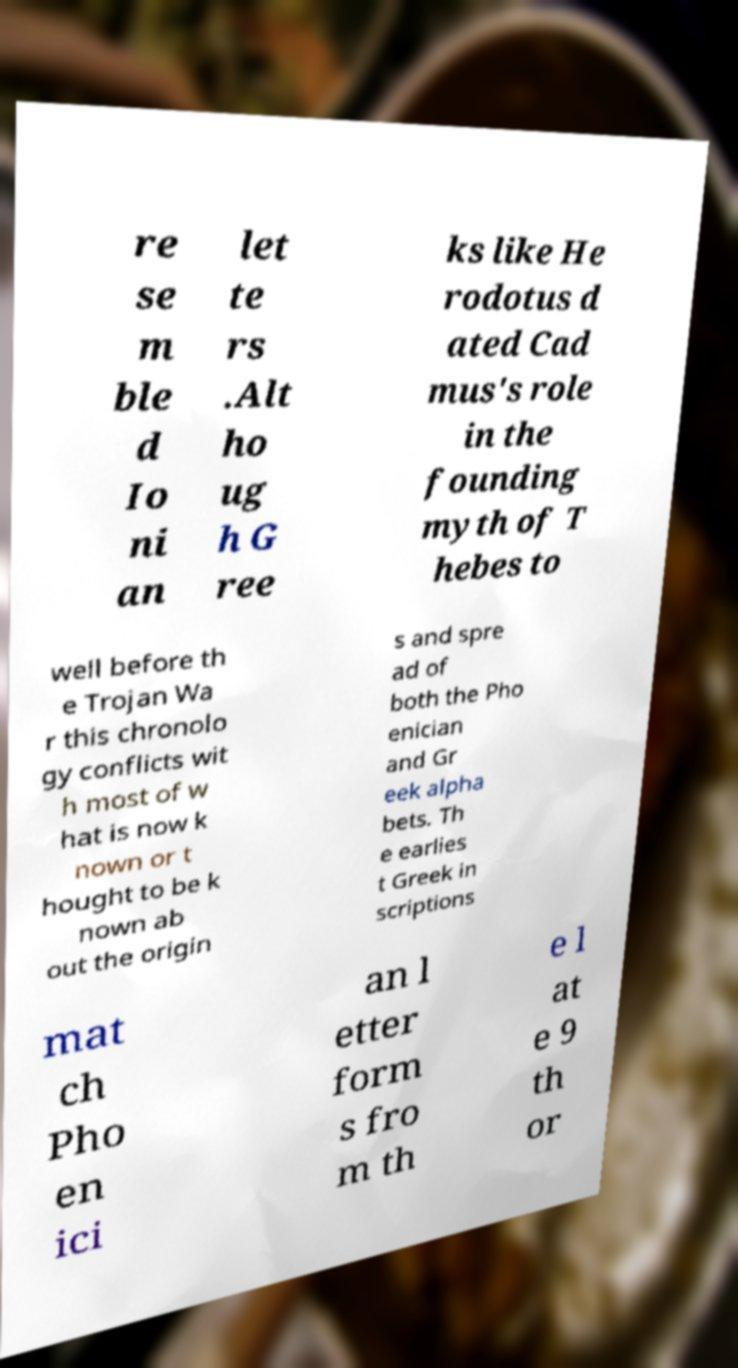Please identify and transcribe the text found in this image. re se m ble d Io ni an let te rs .Alt ho ug h G ree ks like He rodotus d ated Cad mus's role in the founding myth of T hebes to well before th e Trojan Wa r this chronolo gy conflicts wit h most of w hat is now k nown or t hought to be k nown ab out the origin s and spre ad of both the Pho enician and Gr eek alpha bets. Th e earlies t Greek in scriptions mat ch Pho en ici an l etter form s fro m th e l at e 9 th or 